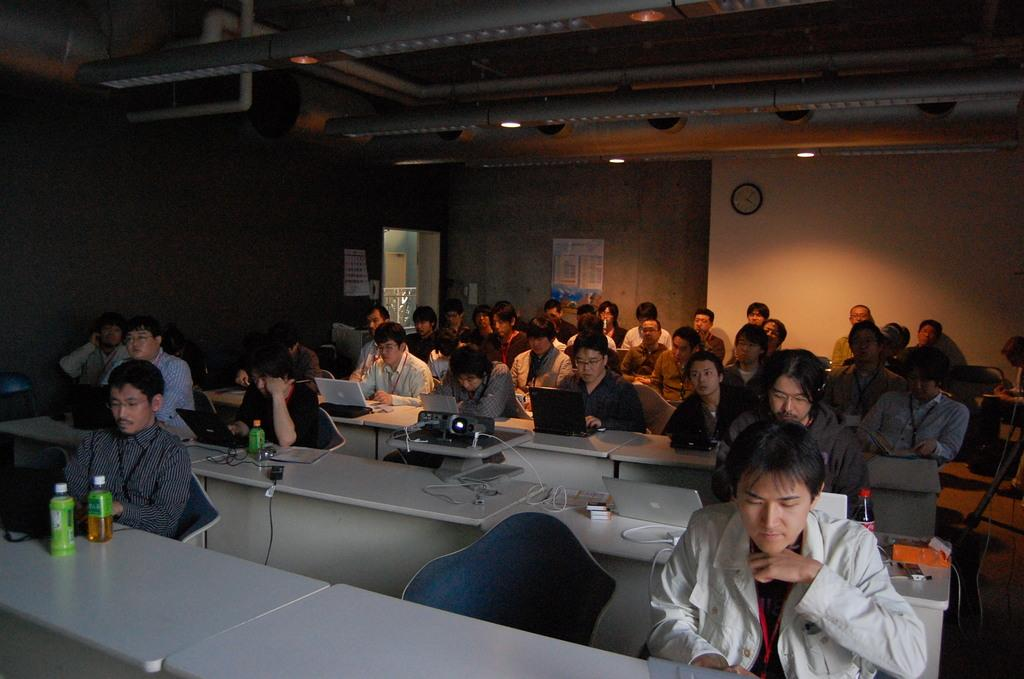How many people are in the image? There is a group of people in the image, but the exact number is not specified. What are the people doing in the image? The people are sitting in chairs in the image. What is on the table in front of the people? There are laptops present on the table in the image. What device is used for displaying information in the image? There is a projector in front of the people in the image. What type of riddle can be solved using the calculator on the table? There is no calculator present in the image, and therefore no riddle can be solved using it. 